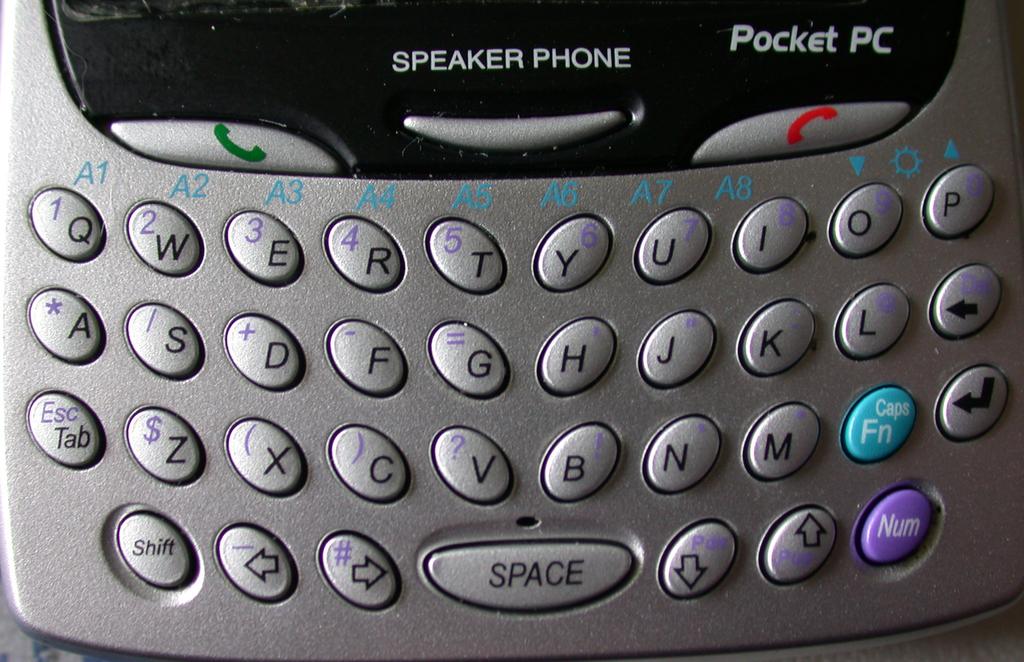What kind of phone does it say?
Offer a terse response. Pocket pc. What button is the last middle button?
Make the answer very short. Space. 